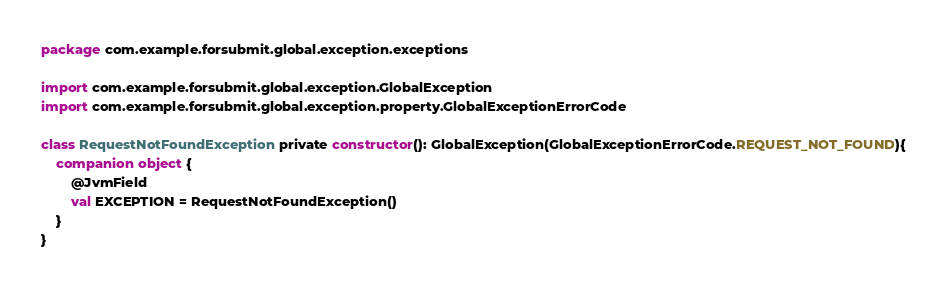<code> <loc_0><loc_0><loc_500><loc_500><_Kotlin_>package com.example.forsubmit.global.exception.exceptions

import com.example.forsubmit.global.exception.GlobalException
import com.example.forsubmit.global.exception.property.GlobalExceptionErrorCode

class RequestNotFoundException private constructor(): GlobalException(GlobalExceptionErrorCode.REQUEST_NOT_FOUND){
    companion object {
        @JvmField
        val EXCEPTION = RequestNotFoundException()
    }
}</code> 